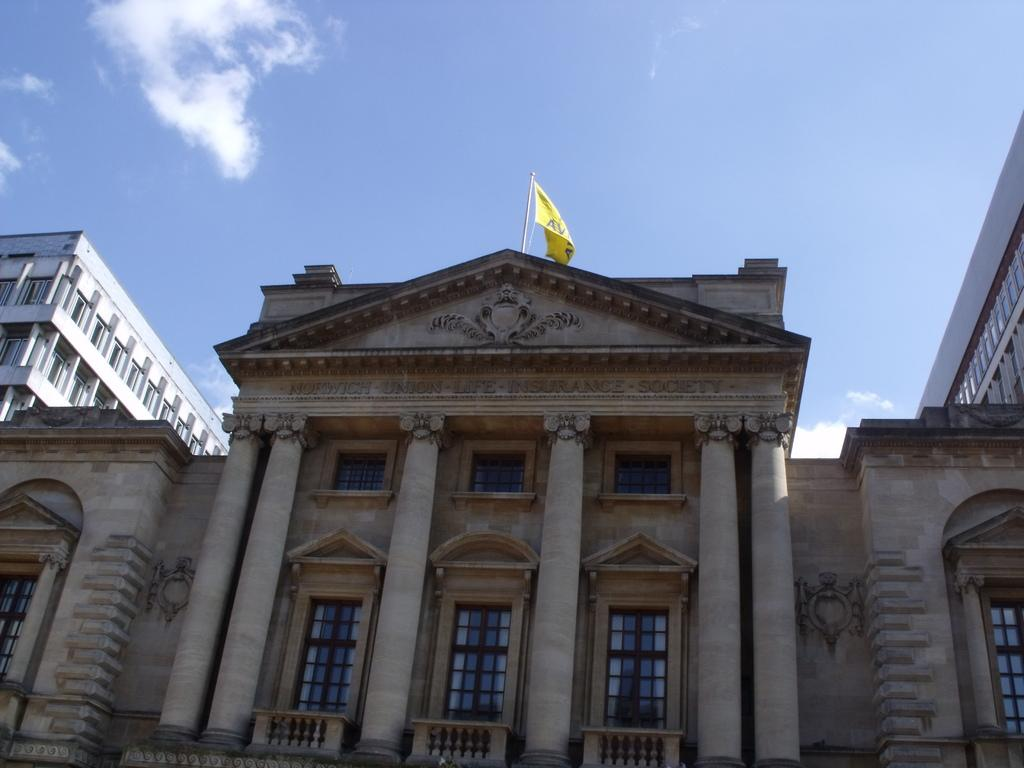What type of structure is visible in the image? There is a building in the image. What feature can be observed on the building? The building has glass windows. Are there any architectural elements present in the image? Yes, there are pillars in the image. What color is the flag in the image? The flag in the image is yellow. What colors can be seen in the sky in the image? The sky is blue and white in color. How many dolls are sitting on the pillars in the image? There are no dolls present in the image; it only features a building, glass windows, pillars, a yellow flag, and a blue and white sky. 